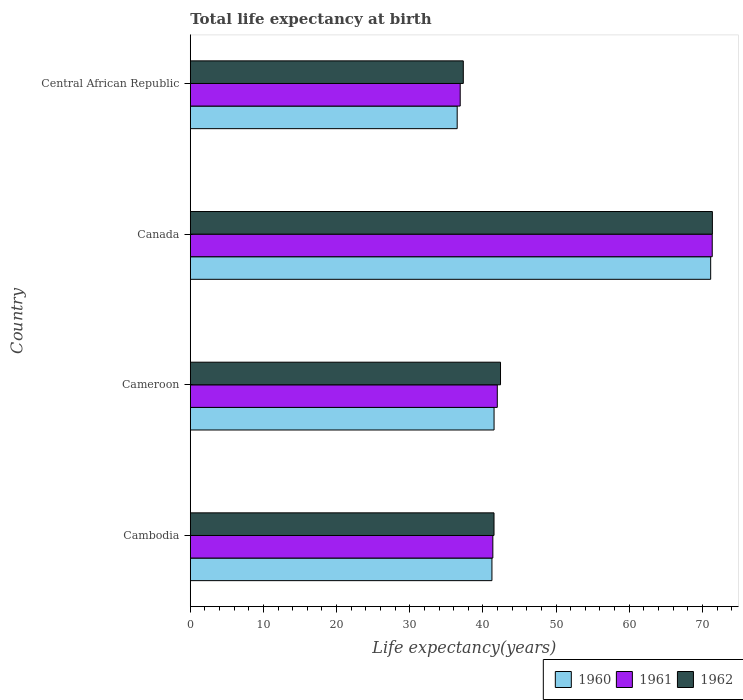How many different coloured bars are there?
Keep it short and to the point. 3. Are the number of bars per tick equal to the number of legend labels?
Ensure brevity in your answer.  Yes. Are the number of bars on each tick of the Y-axis equal?
Your answer should be very brief. Yes. How many bars are there on the 4th tick from the bottom?
Your answer should be compact. 3. What is the label of the 4th group of bars from the top?
Give a very brief answer. Cambodia. In how many cases, is the number of bars for a given country not equal to the number of legend labels?
Give a very brief answer. 0. What is the life expectancy at birth in in 1962 in Cambodia?
Your answer should be very brief. 41.52. Across all countries, what is the maximum life expectancy at birth in in 1960?
Your response must be concise. 71.13. Across all countries, what is the minimum life expectancy at birth in in 1960?
Your response must be concise. 36.48. In which country was the life expectancy at birth in in 1961 minimum?
Provide a succinct answer. Central African Republic. What is the total life expectancy at birth in in 1961 in the graph?
Provide a short and direct response. 191.56. What is the difference between the life expectancy at birth in in 1960 in Cameroon and that in Canada?
Offer a very short reply. -29.61. What is the difference between the life expectancy at birth in in 1962 in Central African Republic and the life expectancy at birth in in 1961 in Canada?
Offer a terse response. -34.03. What is the average life expectancy at birth in in 1960 per country?
Offer a terse response. 47.59. What is the difference between the life expectancy at birth in in 1962 and life expectancy at birth in in 1960 in Cambodia?
Keep it short and to the point. 0.29. What is the ratio of the life expectancy at birth in in 1962 in Cameroon to that in Canada?
Your response must be concise. 0.59. Is the life expectancy at birth in in 1961 in Canada less than that in Central African Republic?
Offer a terse response. No. Is the difference between the life expectancy at birth in in 1962 in Cameroon and Central African Republic greater than the difference between the life expectancy at birth in in 1960 in Cameroon and Central African Republic?
Your response must be concise. Yes. What is the difference between the highest and the second highest life expectancy at birth in in 1962?
Your answer should be very brief. 28.96. What is the difference between the highest and the lowest life expectancy at birth in in 1960?
Provide a short and direct response. 34.65. In how many countries, is the life expectancy at birth in in 1962 greater than the average life expectancy at birth in in 1962 taken over all countries?
Give a very brief answer. 1. What does the 2nd bar from the top in Cambodia represents?
Keep it short and to the point. 1961. What does the 3rd bar from the bottom in Cambodia represents?
Make the answer very short. 1962. How many bars are there?
Your answer should be compact. 12. Are all the bars in the graph horizontal?
Give a very brief answer. Yes. How many countries are there in the graph?
Make the answer very short. 4. Are the values on the major ticks of X-axis written in scientific E-notation?
Make the answer very short. No. Does the graph contain grids?
Your answer should be compact. No. What is the title of the graph?
Offer a terse response. Total life expectancy at birth. What is the label or title of the X-axis?
Keep it short and to the point. Life expectancy(years). What is the label or title of the Y-axis?
Give a very brief answer. Country. What is the Life expectancy(years) in 1960 in Cambodia?
Ensure brevity in your answer.  41.23. What is the Life expectancy(years) in 1961 in Cambodia?
Provide a succinct answer. 41.36. What is the Life expectancy(years) of 1962 in Cambodia?
Make the answer very short. 41.52. What is the Life expectancy(years) in 1960 in Cameroon?
Ensure brevity in your answer.  41.52. What is the Life expectancy(years) of 1961 in Cameroon?
Ensure brevity in your answer.  41.97. What is the Life expectancy(years) of 1962 in Cameroon?
Offer a terse response. 42.41. What is the Life expectancy(years) of 1960 in Canada?
Ensure brevity in your answer.  71.13. What is the Life expectancy(years) of 1961 in Canada?
Keep it short and to the point. 71.35. What is the Life expectancy(years) of 1962 in Canada?
Offer a very short reply. 71.37. What is the Life expectancy(years) of 1960 in Central African Republic?
Keep it short and to the point. 36.48. What is the Life expectancy(years) of 1961 in Central African Republic?
Provide a succinct answer. 36.9. What is the Life expectancy(years) of 1962 in Central African Republic?
Your answer should be very brief. 37.32. Across all countries, what is the maximum Life expectancy(years) of 1960?
Make the answer very short. 71.13. Across all countries, what is the maximum Life expectancy(years) in 1961?
Your answer should be very brief. 71.35. Across all countries, what is the maximum Life expectancy(years) of 1962?
Your answer should be compact. 71.37. Across all countries, what is the minimum Life expectancy(years) of 1960?
Provide a succinct answer. 36.48. Across all countries, what is the minimum Life expectancy(years) in 1961?
Make the answer very short. 36.9. Across all countries, what is the minimum Life expectancy(years) in 1962?
Ensure brevity in your answer.  37.32. What is the total Life expectancy(years) in 1960 in the graph?
Offer a terse response. 190.37. What is the total Life expectancy(years) in 1961 in the graph?
Provide a succinct answer. 191.56. What is the total Life expectancy(years) of 1962 in the graph?
Make the answer very short. 192.61. What is the difference between the Life expectancy(years) of 1960 in Cambodia and that in Cameroon?
Ensure brevity in your answer.  -0.29. What is the difference between the Life expectancy(years) in 1961 in Cambodia and that in Cameroon?
Ensure brevity in your answer.  -0.61. What is the difference between the Life expectancy(years) in 1962 in Cambodia and that in Cameroon?
Provide a short and direct response. -0.89. What is the difference between the Life expectancy(years) of 1960 in Cambodia and that in Canada?
Your answer should be very brief. -29.9. What is the difference between the Life expectancy(years) of 1961 in Cambodia and that in Canada?
Provide a short and direct response. -29.99. What is the difference between the Life expectancy(years) in 1962 in Cambodia and that in Canada?
Provide a short and direct response. -29.85. What is the difference between the Life expectancy(years) in 1960 in Cambodia and that in Central African Republic?
Ensure brevity in your answer.  4.75. What is the difference between the Life expectancy(years) in 1961 in Cambodia and that in Central African Republic?
Your response must be concise. 4.46. What is the difference between the Life expectancy(years) in 1962 in Cambodia and that in Central African Republic?
Keep it short and to the point. 4.2. What is the difference between the Life expectancy(years) in 1960 in Cameroon and that in Canada?
Make the answer very short. -29.61. What is the difference between the Life expectancy(years) in 1961 in Cameroon and that in Canada?
Offer a terse response. -29.38. What is the difference between the Life expectancy(years) in 1962 in Cameroon and that in Canada?
Give a very brief answer. -28.96. What is the difference between the Life expectancy(years) of 1960 in Cameroon and that in Central African Republic?
Give a very brief answer. 5.04. What is the difference between the Life expectancy(years) of 1961 in Cameroon and that in Central African Republic?
Offer a terse response. 5.07. What is the difference between the Life expectancy(years) of 1962 in Cameroon and that in Central African Republic?
Ensure brevity in your answer.  5.09. What is the difference between the Life expectancy(years) of 1960 in Canada and that in Central African Republic?
Give a very brief answer. 34.65. What is the difference between the Life expectancy(years) of 1961 in Canada and that in Central African Republic?
Offer a very short reply. 34.45. What is the difference between the Life expectancy(years) of 1962 in Canada and that in Central African Republic?
Your response must be concise. 34.05. What is the difference between the Life expectancy(years) in 1960 in Cambodia and the Life expectancy(years) in 1961 in Cameroon?
Ensure brevity in your answer.  -0.73. What is the difference between the Life expectancy(years) of 1960 in Cambodia and the Life expectancy(years) of 1962 in Cameroon?
Ensure brevity in your answer.  -1.17. What is the difference between the Life expectancy(years) of 1961 in Cambodia and the Life expectancy(years) of 1962 in Cameroon?
Make the answer very short. -1.05. What is the difference between the Life expectancy(years) of 1960 in Cambodia and the Life expectancy(years) of 1961 in Canada?
Offer a very short reply. -30.11. What is the difference between the Life expectancy(years) of 1960 in Cambodia and the Life expectancy(years) of 1962 in Canada?
Offer a terse response. -30.14. What is the difference between the Life expectancy(years) in 1961 in Cambodia and the Life expectancy(years) in 1962 in Canada?
Ensure brevity in your answer.  -30.01. What is the difference between the Life expectancy(years) of 1960 in Cambodia and the Life expectancy(years) of 1961 in Central African Republic?
Your answer should be compact. 4.34. What is the difference between the Life expectancy(years) in 1960 in Cambodia and the Life expectancy(years) in 1962 in Central African Republic?
Keep it short and to the point. 3.91. What is the difference between the Life expectancy(years) of 1961 in Cambodia and the Life expectancy(years) of 1962 in Central African Republic?
Give a very brief answer. 4.04. What is the difference between the Life expectancy(years) of 1960 in Cameroon and the Life expectancy(years) of 1961 in Canada?
Provide a succinct answer. -29.82. What is the difference between the Life expectancy(years) of 1960 in Cameroon and the Life expectancy(years) of 1962 in Canada?
Keep it short and to the point. -29.84. What is the difference between the Life expectancy(years) of 1961 in Cameroon and the Life expectancy(years) of 1962 in Canada?
Ensure brevity in your answer.  -29.4. What is the difference between the Life expectancy(years) in 1960 in Cameroon and the Life expectancy(years) in 1961 in Central African Republic?
Make the answer very short. 4.63. What is the difference between the Life expectancy(years) of 1960 in Cameroon and the Life expectancy(years) of 1962 in Central African Republic?
Offer a terse response. 4.21. What is the difference between the Life expectancy(years) of 1961 in Cameroon and the Life expectancy(years) of 1962 in Central African Republic?
Ensure brevity in your answer.  4.65. What is the difference between the Life expectancy(years) in 1960 in Canada and the Life expectancy(years) in 1961 in Central African Republic?
Keep it short and to the point. 34.24. What is the difference between the Life expectancy(years) in 1960 in Canada and the Life expectancy(years) in 1962 in Central African Republic?
Your answer should be compact. 33.81. What is the difference between the Life expectancy(years) of 1961 in Canada and the Life expectancy(years) of 1962 in Central African Republic?
Offer a very short reply. 34.03. What is the average Life expectancy(years) in 1960 per country?
Provide a succinct answer. 47.59. What is the average Life expectancy(years) of 1961 per country?
Offer a very short reply. 47.89. What is the average Life expectancy(years) of 1962 per country?
Your response must be concise. 48.15. What is the difference between the Life expectancy(years) of 1960 and Life expectancy(years) of 1961 in Cambodia?
Your answer should be compact. -0.13. What is the difference between the Life expectancy(years) of 1960 and Life expectancy(years) of 1962 in Cambodia?
Your answer should be compact. -0.29. What is the difference between the Life expectancy(years) in 1961 and Life expectancy(years) in 1962 in Cambodia?
Provide a succinct answer. -0.16. What is the difference between the Life expectancy(years) in 1960 and Life expectancy(years) in 1961 in Cameroon?
Keep it short and to the point. -0.44. What is the difference between the Life expectancy(years) in 1960 and Life expectancy(years) in 1962 in Cameroon?
Your response must be concise. -0.88. What is the difference between the Life expectancy(years) in 1961 and Life expectancy(years) in 1962 in Cameroon?
Give a very brief answer. -0.44. What is the difference between the Life expectancy(years) of 1960 and Life expectancy(years) of 1961 in Canada?
Your answer should be compact. -0.21. What is the difference between the Life expectancy(years) of 1960 and Life expectancy(years) of 1962 in Canada?
Give a very brief answer. -0.23. What is the difference between the Life expectancy(years) of 1961 and Life expectancy(years) of 1962 in Canada?
Your answer should be compact. -0.02. What is the difference between the Life expectancy(years) in 1960 and Life expectancy(years) in 1961 in Central African Republic?
Make the answer very short. -0.41. What is the difference between the Life expectancy(years) of 1960 and Life expectancy(years) of 1962 in Central African Republic?
Give a very brief answer. -0.84. What is the difference between the Life expectancy(years) of 1961 and Life expectancy(years) of 1962 in Central African Republic?
Offer a very short reply. -0.42. What is the ratio of the Life expectancy(years) of 1960 in Cambodia to that in Cameroon?
Your answer should be compact. 0.99. What is the ratio of the Life expectancy(years) in 1961 in Cambodia to that in Cameroon?
Provide a succinct answer. 0.99. What is the ratio of the Life expectancy(years) of 1962 in Cambodia to that in Cameroon?
Give a very brief answer. 0.98. What is the ratio of the Life expectancy(years) of 1960 in Cambodia to that in Canada?
Your answer should be very brief. 0.58. What is the ratio of the Life expectancy(years) in 1961 in Cambodia to that in Canada?
Ensure brevity in your answer.  0.58. What is the ratio of the Life expectancy(years) of 1962 in Cambodia to that in Canada?
Your response must be concise. 0.58. What is the ratio of the Life expectancy(years) of 1960 in Cambodia to that in Central African Republic?
Provide a short and direct response. 1.13. What is the ratio of the Life expectancy(years) of 1961 in Cambodia to that in Central African Republic?
Your answer should be compact. 1.12. What is the ratio of the Life expectancy(years) of 1962 in Cambodia to that in Central African Republic?
Keep it short and to the point. 1.11. What is the ratio of the Life expectancy(years) in 1960 in Cameroon to that in Canada?
Keep it short and to the point. 0.58. What is the ratio of the Life expectancy(years) in 1961 in Cameroon to that in Canada?
Your response must be concise. 0.59. What is the ratio of the Life expectancy(years) in 1962 in Cameroon to that in Canada?
Your response must be concise. 0.59. What is the ratio of the Life expectancy(years) in 1960 in Cameroon to that in Central African Republic?
Provide a succinct answer. 1.14. What is the ratio of the Life expectancy(years) of 1961 in Cameroon to that in Central African Republic?
Your answer should be very brief. 1.14. What is the ratio of the Life expectancy(years) in 1962 in Cameroon to that in Central African Republic?
Provide a succinct answer. 1.14. What is the ratio of the Life expectancy(years) in 1960 in Canada to that in Central African Republic?
Provide a short and direct response. 1.95. What is the ratio of the Life expectancy(years) of 1961 in Canada to that in Central African Republic?
Offer a very short reply. 1.93. What is the ratio of the Life expectancy(years) of 1962 in Canada to that in Central African Republic?
Provide a short and direct response. 1.91. What is the difference between the highest and the second highest Life expectancy(years) in 1960?
Ensure brevity in your answer.  29.61. What is the difference between the highest and the second highest Life expectancy(years) of 1961?
Your answer should be very brief. 29.38. What is the difference between the highest and the second highest Life expectancy(years) in 1962?
Your answer should be very brief. 28.96. What is the difference between the highest and the lowest Life expectancy(years) in 1960?
Keep it short and to the point. 34.65. What is the difference between the highest and the lowest Life expectancy(years) in 1961?
Keep it short and to the point. 34.45. What is the difference between the highest and the lowest Life expectancy(years) of 1962?
Provide a short and direct response. 34.05. 